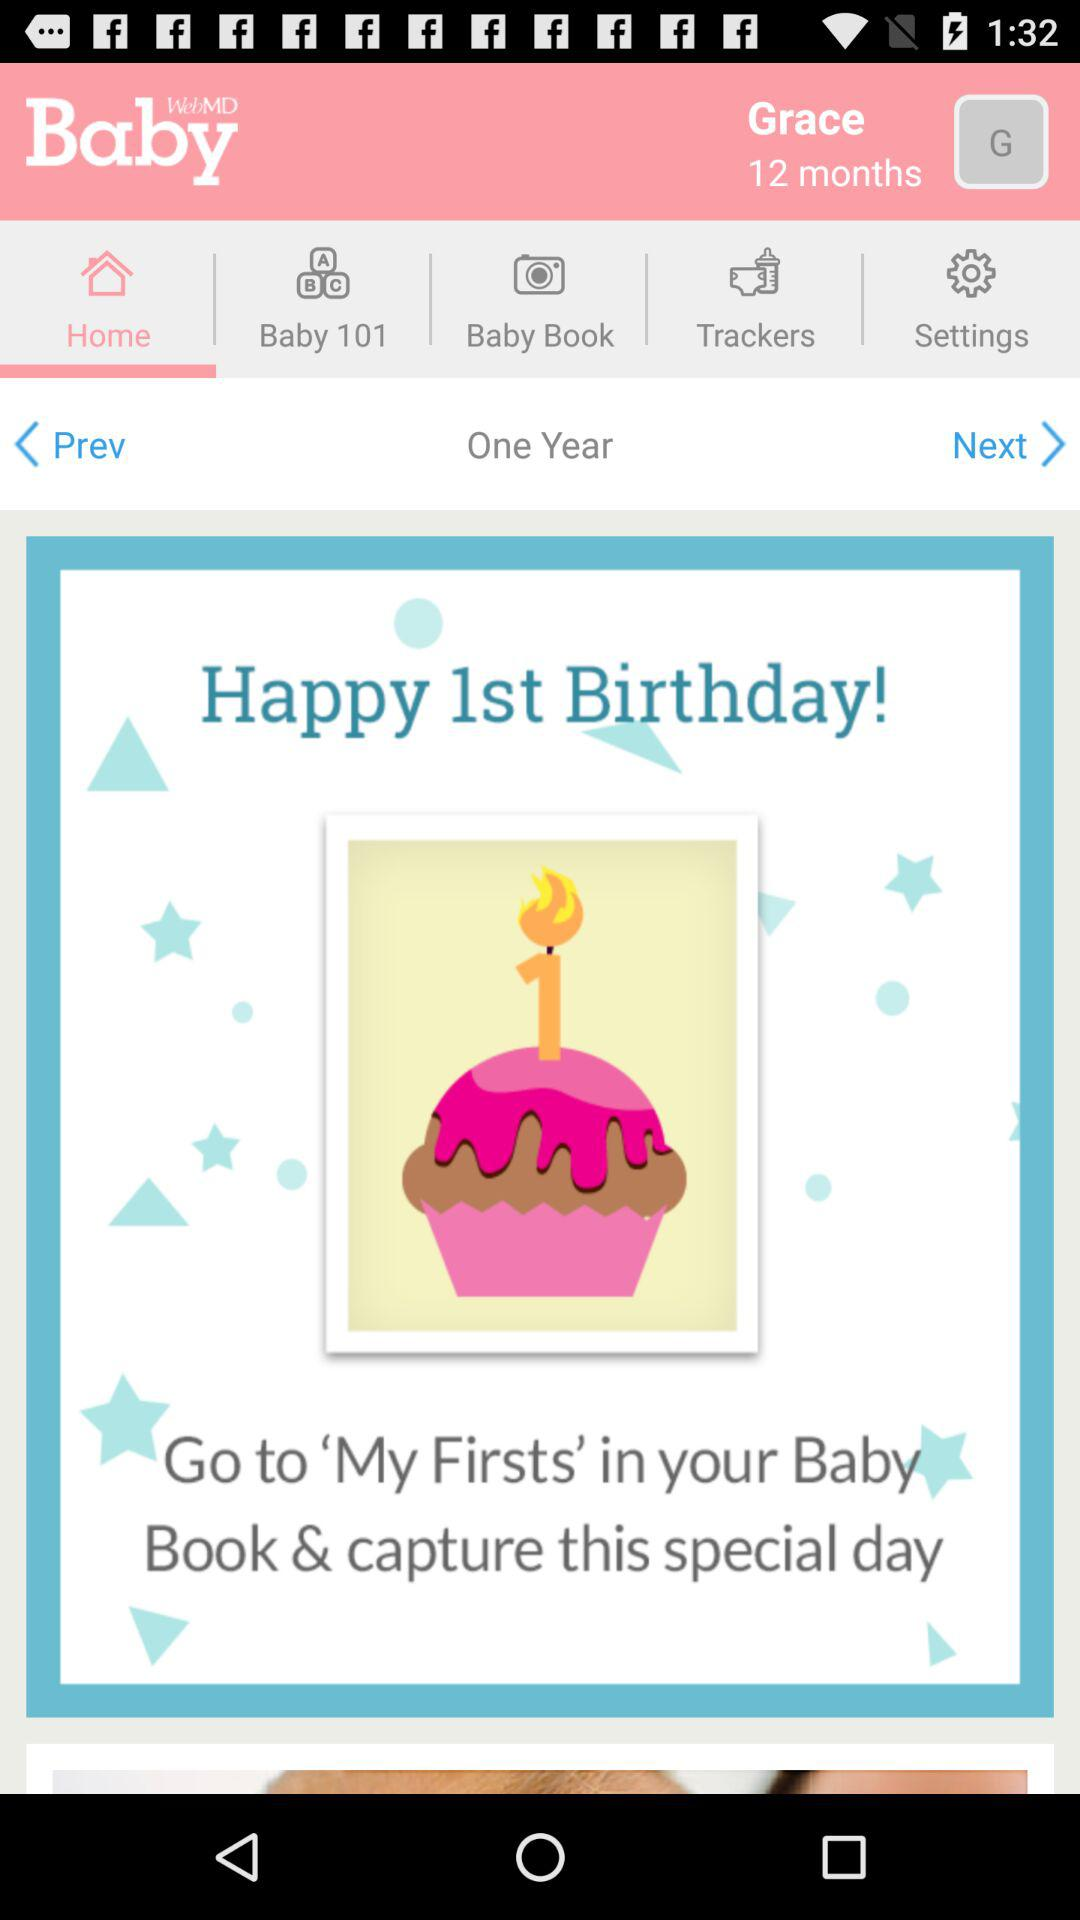What is the name of the baby? The name of the baby is Grace. 